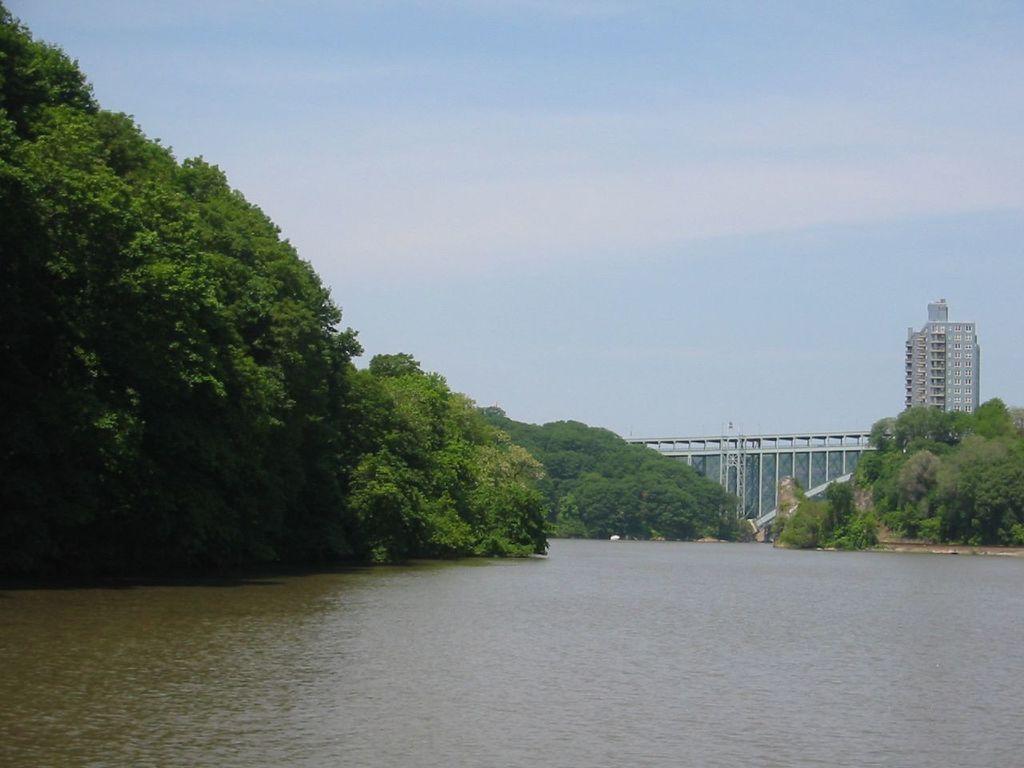In one or two sentences, can you explain what this image depicts? In this picture we can see the river and trees and in the background we can see a bridge, building and the sky. 